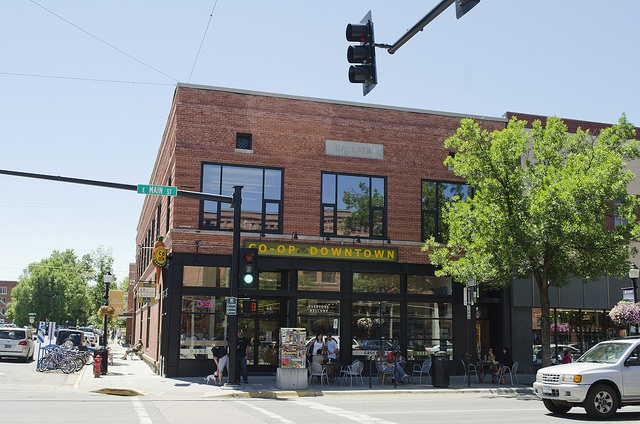Describe the objects in this image and their specific colors. I can see car in lavender, darkgray, black, white, and gray tones, traffic light in lavender, black, lightblue, and gray tones, car in lavender, darkgray, black, and gray tones, traffic light in lavender, black, white, maroon, and gray tones, and people in lavender, black, and gray tones in this image. 